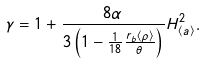Convert formula to latex. <formula><loc_0><loc_0><loc_500><loc_500>\gamma = 1 + \frac { 8 \alpha } { 3 \left ( 1 - \frac { 1 } { 1 8 } \frac { r _ { b } \left \langle \rho \right \rangle } { \theta } \right ) } H _ { \left \langle a \right \rangle } ^ { 2 } .</formula> 